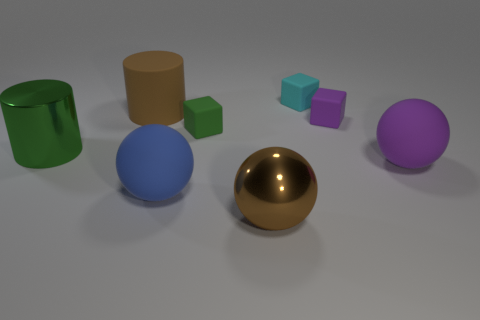How many spheres are either tiny cyan shiny objects or large purple matte things?
Make the answer very short. 1. Is the number of green cylinders that are on the right side of the large brown metal object the same as the number of small purple blocks that are to the left of the large metallic cylinder?
Offer a very short reply. Yes. There is a large matte thing that is behind the large metal thing behind the blue object; how many small green objects are behind it?
Make the answer very short. 0. There is a object that is the same color as the matte cylinder; what shape is it?
Offer a very short reply. Sphere. Is the color of the metallic sphere the same as the large matte thing behind the purple sphere?
Ensure brevity in your answer.  Yes. Are there more rubber things in front of the small purple rubber block than small brown matte cubes?
Provide a succinct answer. Yes. What number of things are either big brown things behind the green matte thing or big objects on the left side of the big purple rubber ball?
Provide a short and direct response. 4. There is another sphere that is the same material as the blue sphere; what is its size?
Give a very brief answer. Large. Is the shape of the green object right of the big green metallic cylinder the same as  the tiny cyan thing?
Give a very brief answer. Yes. What is the size of the rubber thing that is the same color as the big metal cylinder?
Keep it short and to the point. Small. 